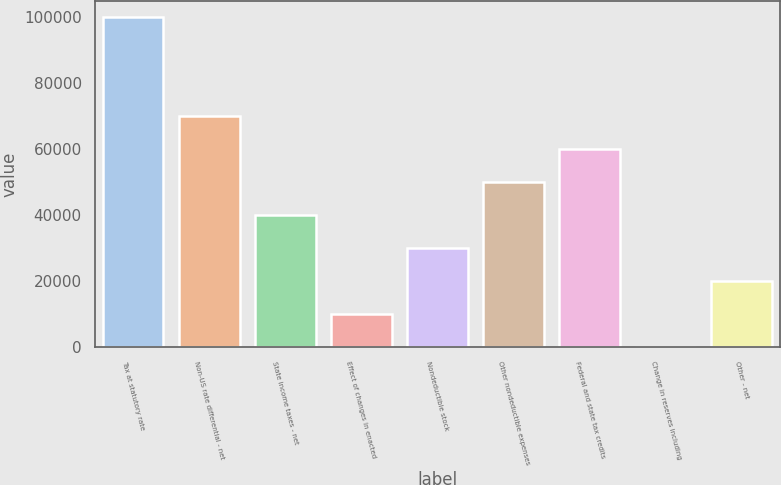Convert chart to OTSL. <chart><loc_0><loc_0><loc_500><loc_500><bar_chart><fcel>Tax at statutory rate<fcel>Non-US rate differential - net<fcel>State income taxes - net<fcel>Effect of changes in enacted<fcel>Nondeductible stock<fcel>Other nondeductible expenses<fcel>Federal and state tax credits<fcel>Change in reserves including<fcel>Other - net<nl><fcel>99867<fcel>69909<fcel>39951<fcel>9993<fcel>29965<fcel>49937<fcel>59923<fcel>7<fcel>19979<nl></chart> 